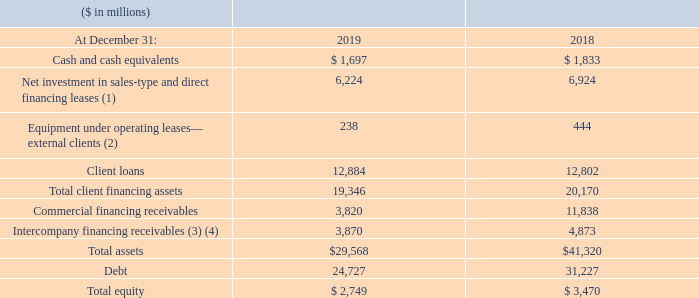Global Financing Financial Position Key Metrics
(1) Includes deferred initial direct costs which are eliminated in
IBM’s consolidated results.
(2) Includes intercompany mark-up, priced on an arm’s-length basis, on products purchased from the company’s product divisions which is eliminated in IBM’s consolidated results.
(3) Entire amount eliminated for purposes of IBM’s consolidated results and therefore does not appear in the Consolidated Balance Sheet.
(4) These assets, along with all other financing assets in this table, are
leveraged at the value in the table using Global Financing debt.
At December 31, 2019, substantially all financing assets were IT-related assets, and approximately 62 percent of the total external portfolio was with investment-grade clients with no direct exposure to consumers, an increase of 7 points year to year. This investment-grade percentage is based on the credit ratings of the companies in the portfolio.
We have a long-standing practice of taking mitigation actions, in certain circumstances, to transfer credit risk to third parties, including credit insurance, financial guarantees, nonrecourse borrowings, transfers of receivables recorded as true sales in
accordance with accounting guidance or sales of equipment under operating lease. Adjusting for the mitigation actions, the investment-grade content would increase to 67 percent, a decrease of 3 points year to year.
What percent of the total external portfolio was with investment-grade clients with no direct exposure to consumers? 62 percent. What will be the increase in the investment grade post adjusting for mitigation actions? 67 percent. What was the available cash in 2019?
Answer scale should be: million. $ 1,697. What is the increase / (decrease) in the cash from 2018 to 2019?
Answer scale should be: million. 1,697 - 1,833
Answer: -136. What is the average of Equipment under operating leases— external clients?
Answer scale should be: million. (238 + 444) / 2
Answer: 341. What is the percentage increase / (decrease) in Total client financing assets from 2018 to 2019? 
Answer scale should be: percent. 19,346 / 20,170 - 1
Answer: -4.09. 